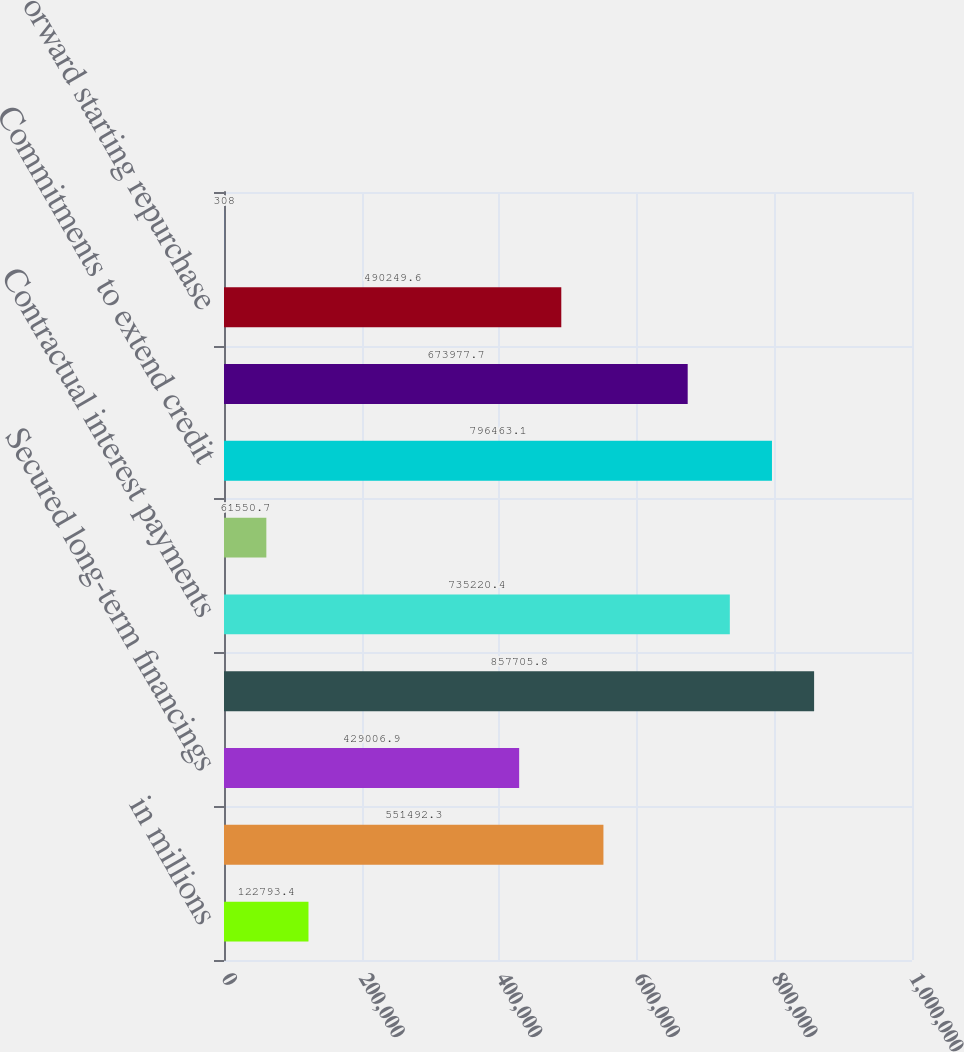Convert chart. <chart><loc_0><loc_0><loc_500><loc_500><bar_chart><fcel>in millions<fcel>Time deposits<fcel>Secured long-term financings<fcel>Unsecured long-term borrowings<fcel>Contractual interest payments<fcel>Subordinated liabilities<fcel>Commitments to extend credit<fcel>Contingent and forward<fcel>Forward starting repurchase<fcel>Letters of credit<nl><fcel>122793<fcel>551492<fcel>429007<fcel>857706<fcel>735220<fcel>61550.7<fcel>796463<fcel>673978<fcel>490250<fcel>308<nl></chart> 